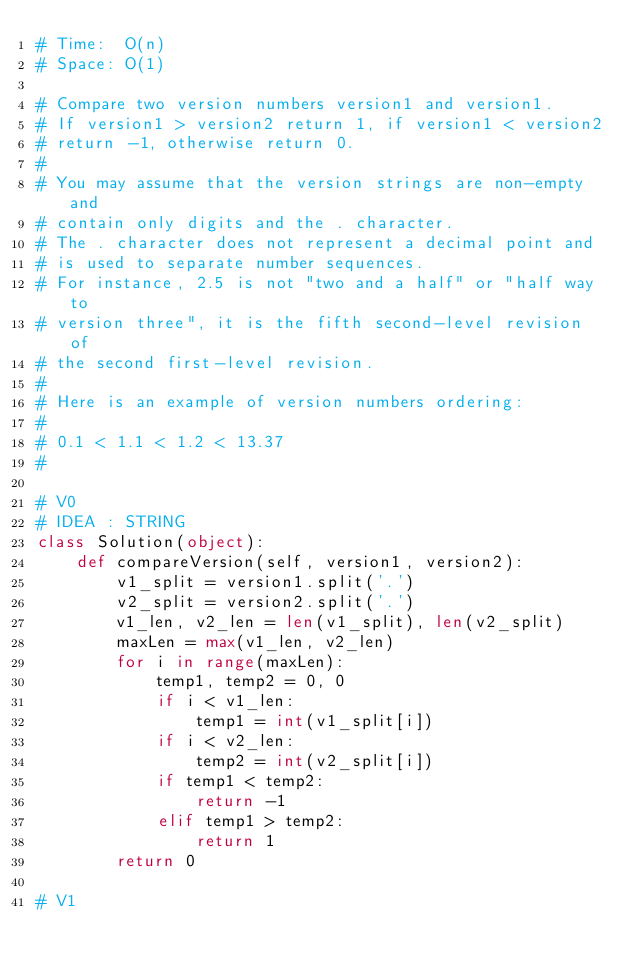Convert code to text. <code><loc_0><loc_0><loc_500><loc_500><_Python_># Time:  O(n)
# Space: O(1)

# Compare two version numbers version1 and version1.
# If version1 > version2 return 1, if version1 < version2
# return -1, otherwise return 0.
#
# You may assume that the version strings are non-empty and
# contain only digits and the . character.
# The . character does not represent a decimal point and
# is used to separate number sequences.
# For instance, 2.5 is not "two and a half" or "half way to
# version three", it is the fifth second-level revision of
# the second first-level revision.
#
# Here is an example of version numbers ordering:
#
# 0.1 < 1.1 < 1.2 < 13.37
#

# V0 
# IDEA : STRING
class Solution(object):
    def compareVersion(self, version1, version2):
        v1_split = version1.split('.')
        v2_split = version2.split('.')
        v1_len, v2_len = len(v1_split), len(v2_split)
        maxLen = max(v1_len, v2_len)
        for i in range(maxLen):
            temp1, temp2 = 0, 0
            if i < v1_len:
                temp1 = int(v1_split[i])
            if i < v2_len:
                temp2 = int(v2_split[i])
            if temp1 < temp2:
                return -1
            elif temp1 > temp2:
                return 1
        return 0

# V1 </code> 